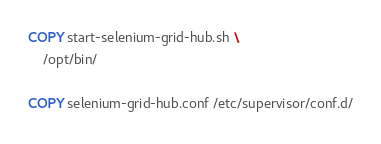<code> <loc_0><loc_0><loc_500><loc_500><_Dockerfile_>
COPY start-selenium-grid-hub.sh \
    /opt/bin/

COPY selenium-grid-hub.conf /etc/supervisor/conf.d/
</code> 